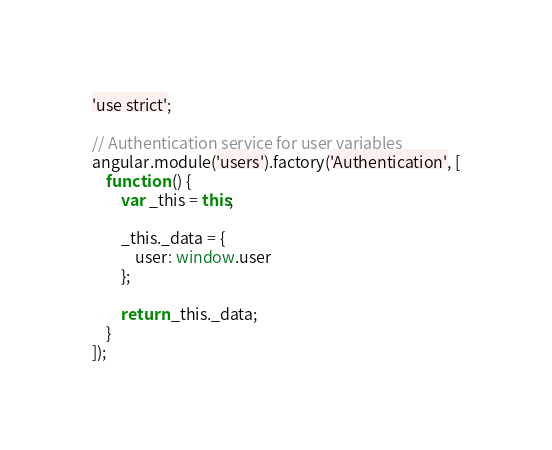Convert code to text. <code><loc_0><loc_0><loc_500><loc_500><_JavaScript_>'use strict';

// Authentication service for user variables
angular.module('users').factory('Authentication', [
    function () {
        var _this = this;

        _this._data = {
            user: window.user
        };

        return _this._data;
    }
]);</code> 